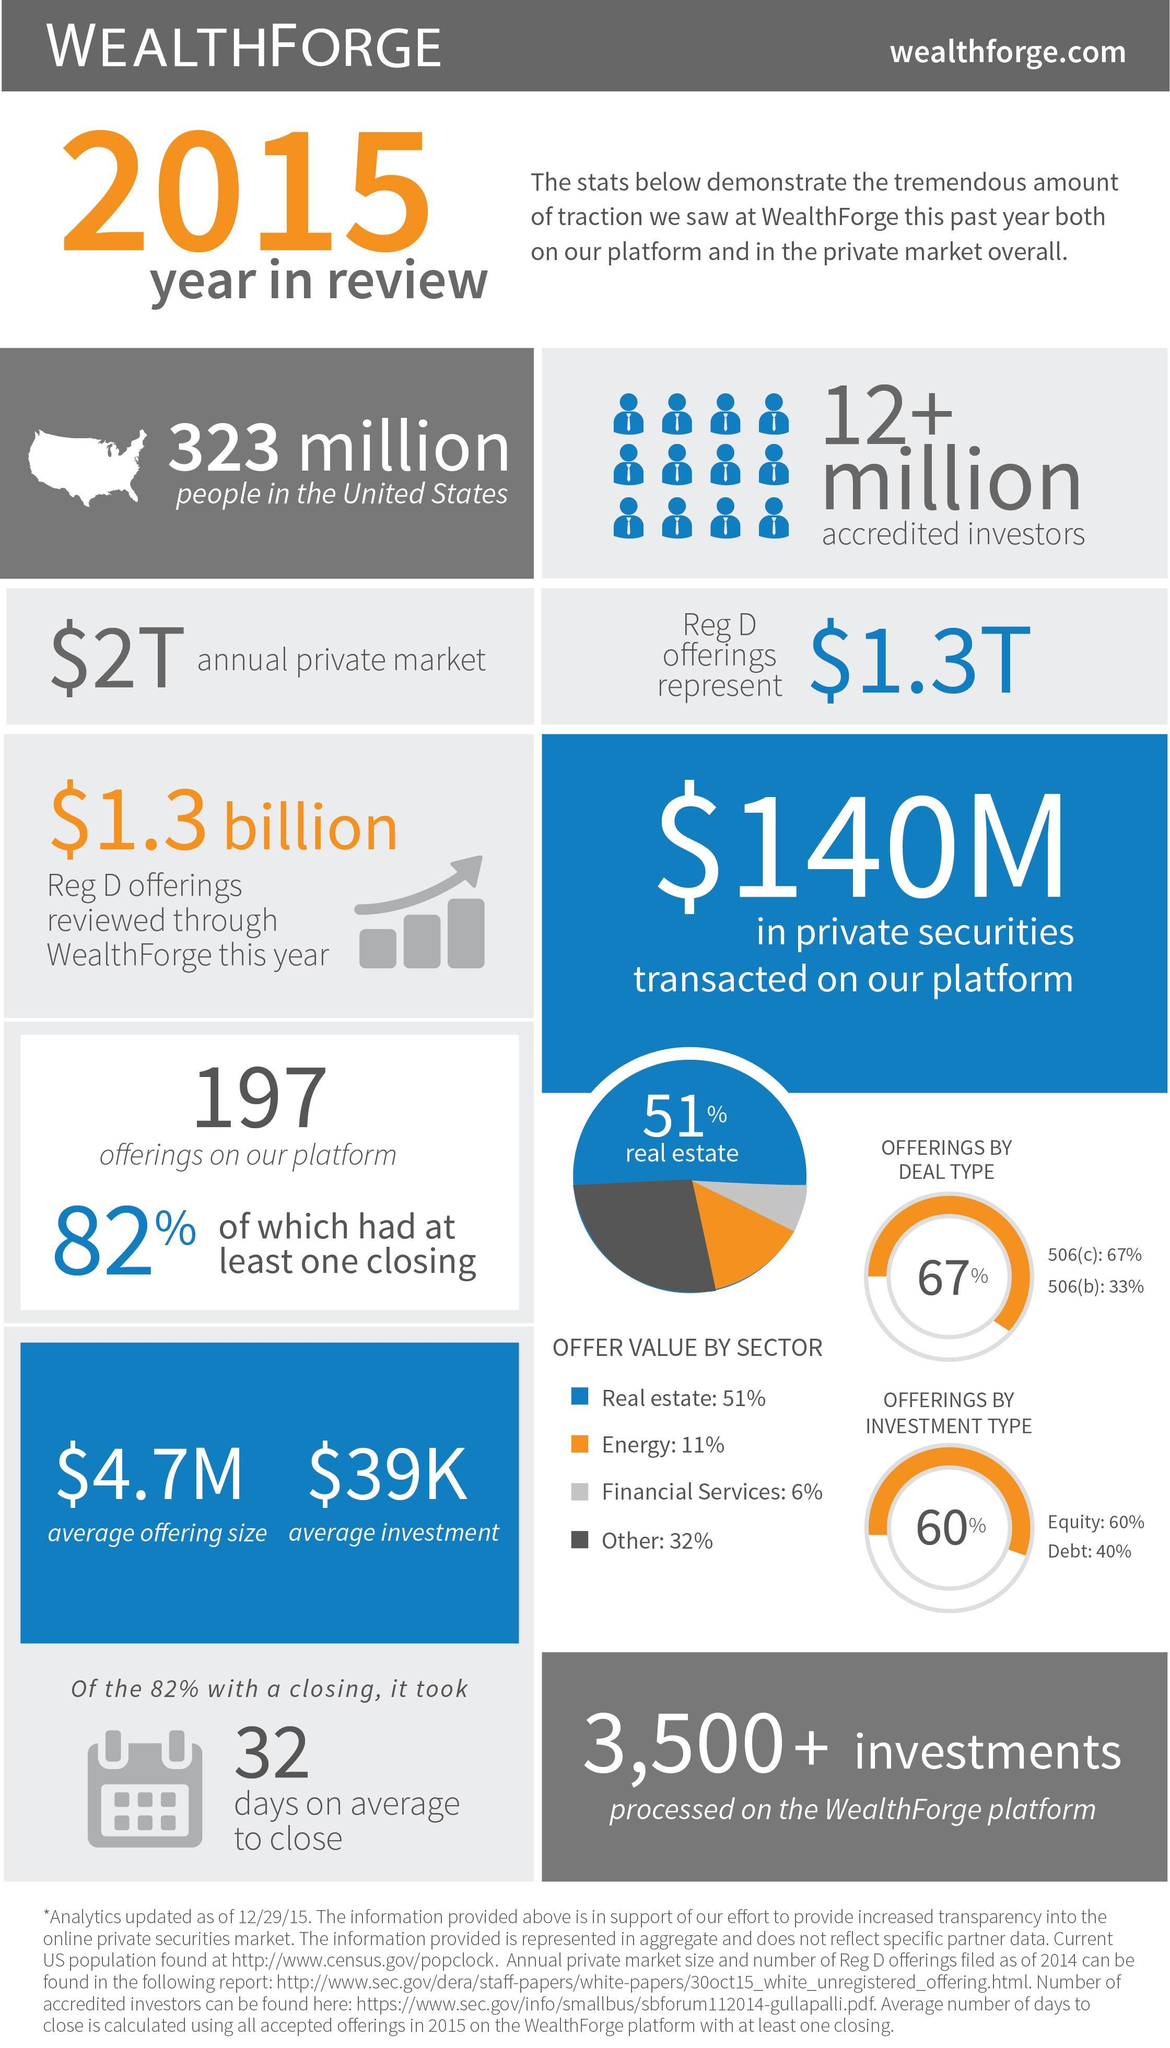What percent of offerings did not have a closing?
Answer the question with a short phrase. 18% Which sector had the highest offer value? Real estate 